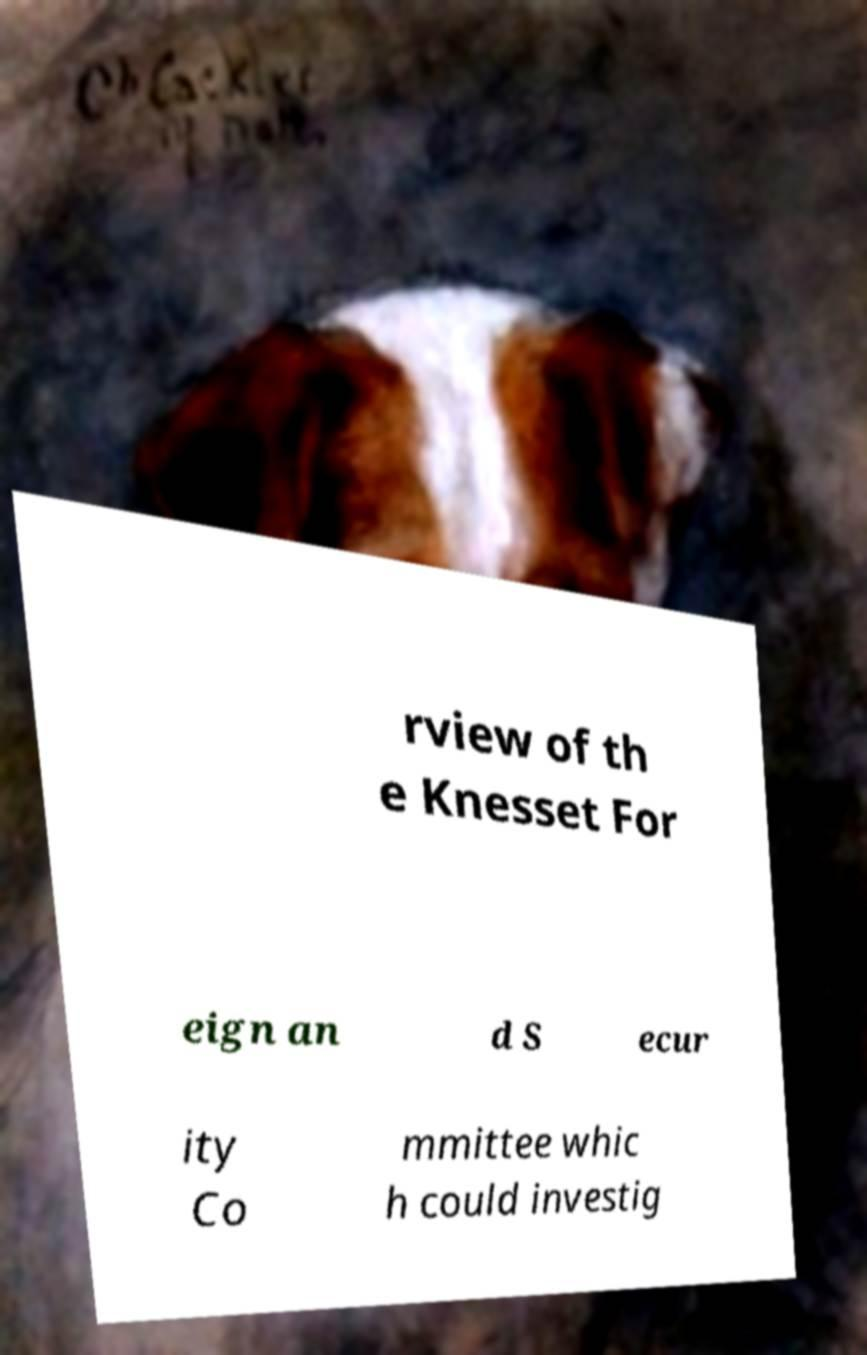I need the written content from this picture converted into text. Can you do that? rview of th e Knesset For eign an d S ecur ity Co mmittee whic h could investig 